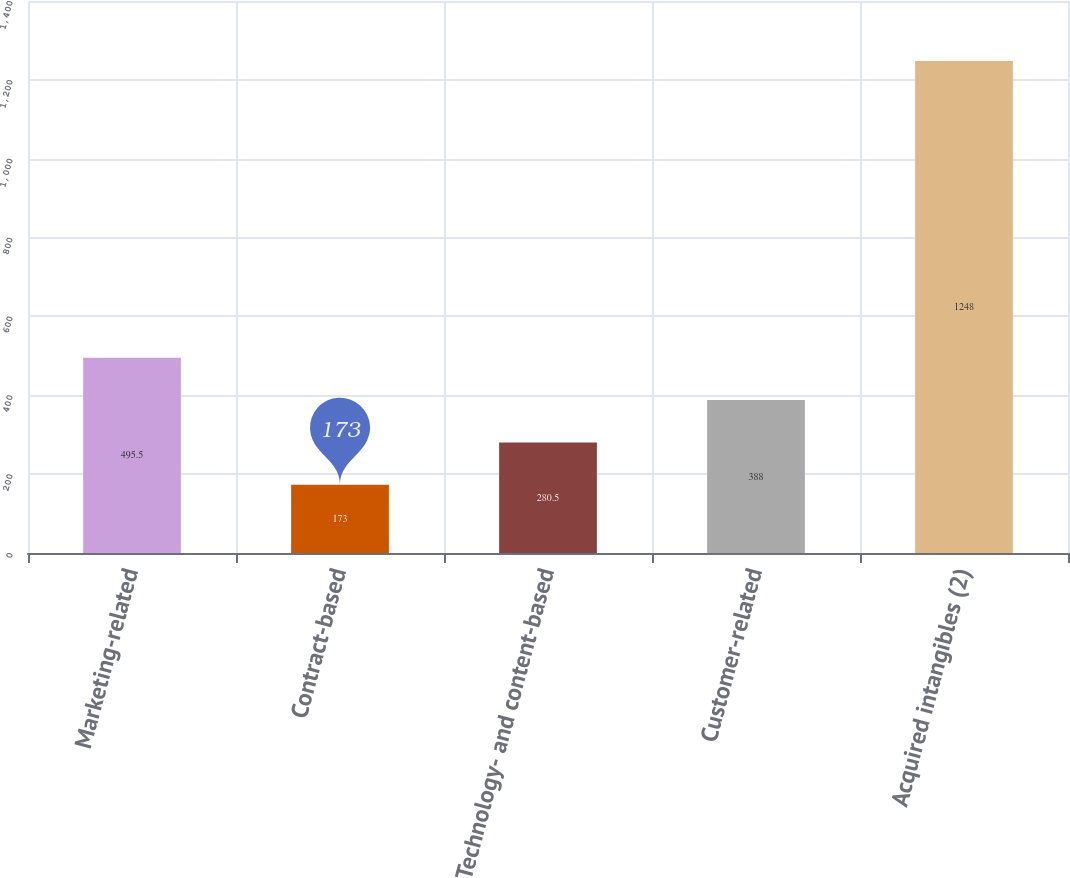Convert chart. <chart><loc_0><loc_0><loc_500><loc_500><bar_chart><fcel>Marketing-related<fcel>Contract-based<fcel>Technology- and content-based<fcel>Customer-related<fcel>Acquired intangibles (2)<nl><fcel>495.5<fcel>173<fcel>280.5<fcel>388<fcel>1248<nl></chart> 